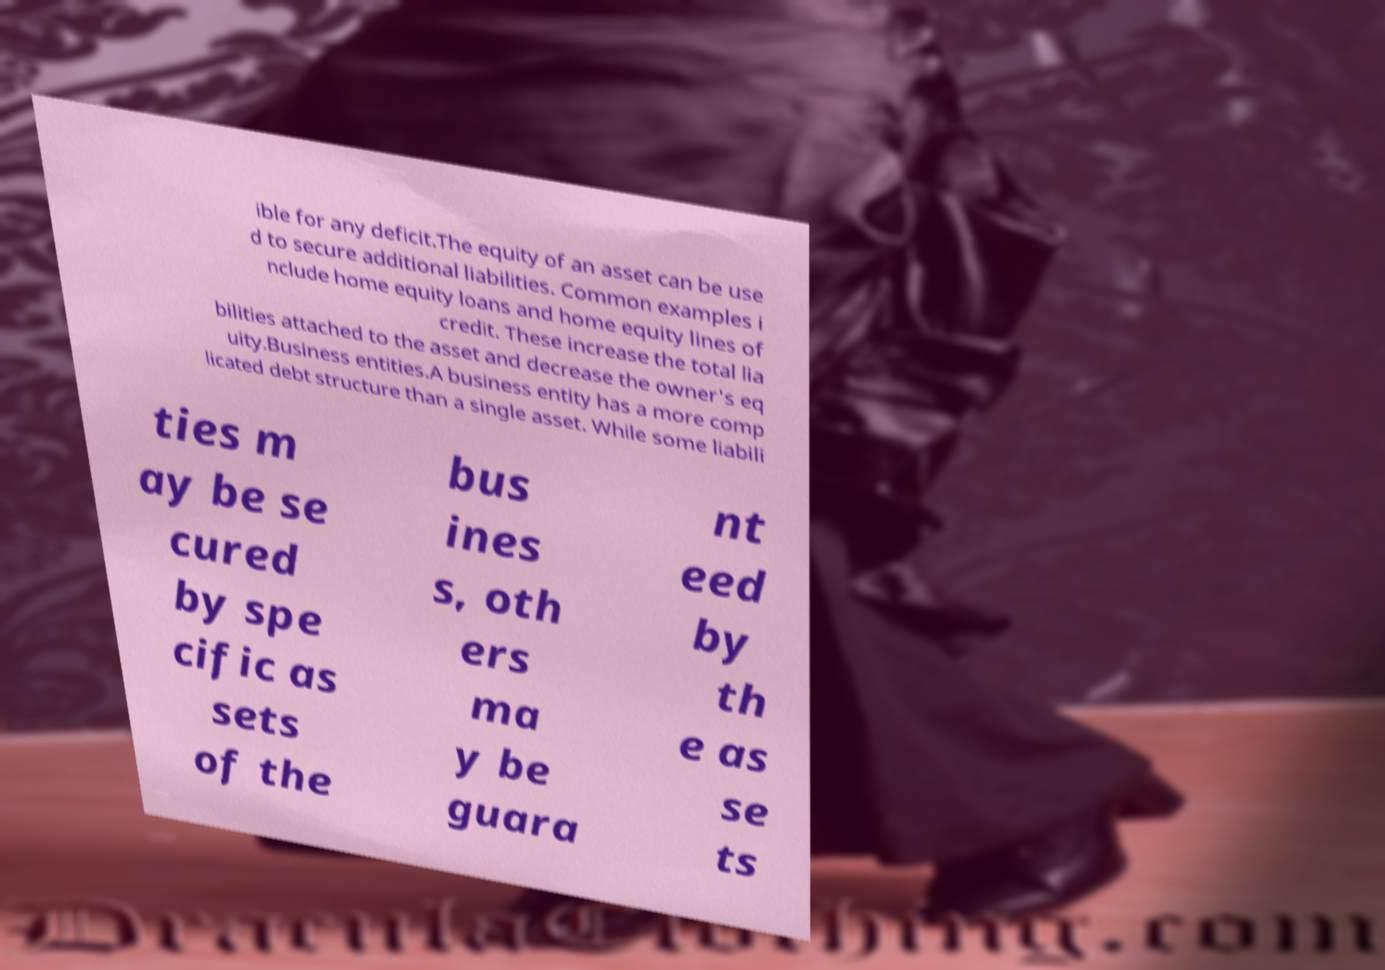There's text embedded in this image that I need extracted. Can you transcribe it verbatim? ible for any deficit.The equity of an asset can be use d to secure additional liabilities. Common examples i nclude home equity loans and home equity lines of credit. These increase the total lia bilities attached to the asset and decrease the owner's eq uity.Business entities.A business entity has a more comp licated debt structure than a single asset. While some liabili ties m ay be se cured by spe cific as sets of the bus ines s, oth ers ma y be guara nt eed by th e as se ts 